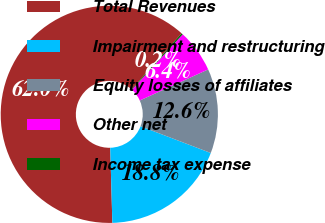Convert chart. <chart><loc_0><loc_0><loc_500><loc_500><pie_chart><fcel>Total Revenues<fcel>Impairment and restructuring<fcel>Equity losses of affiliates<fcel>Other net<fcel>Income tax expense<nl><fcel>62.05%<fcel>18.76%<fcel>12.58%<fcel>6.4%<fcel>0.21%<nl></chart> 